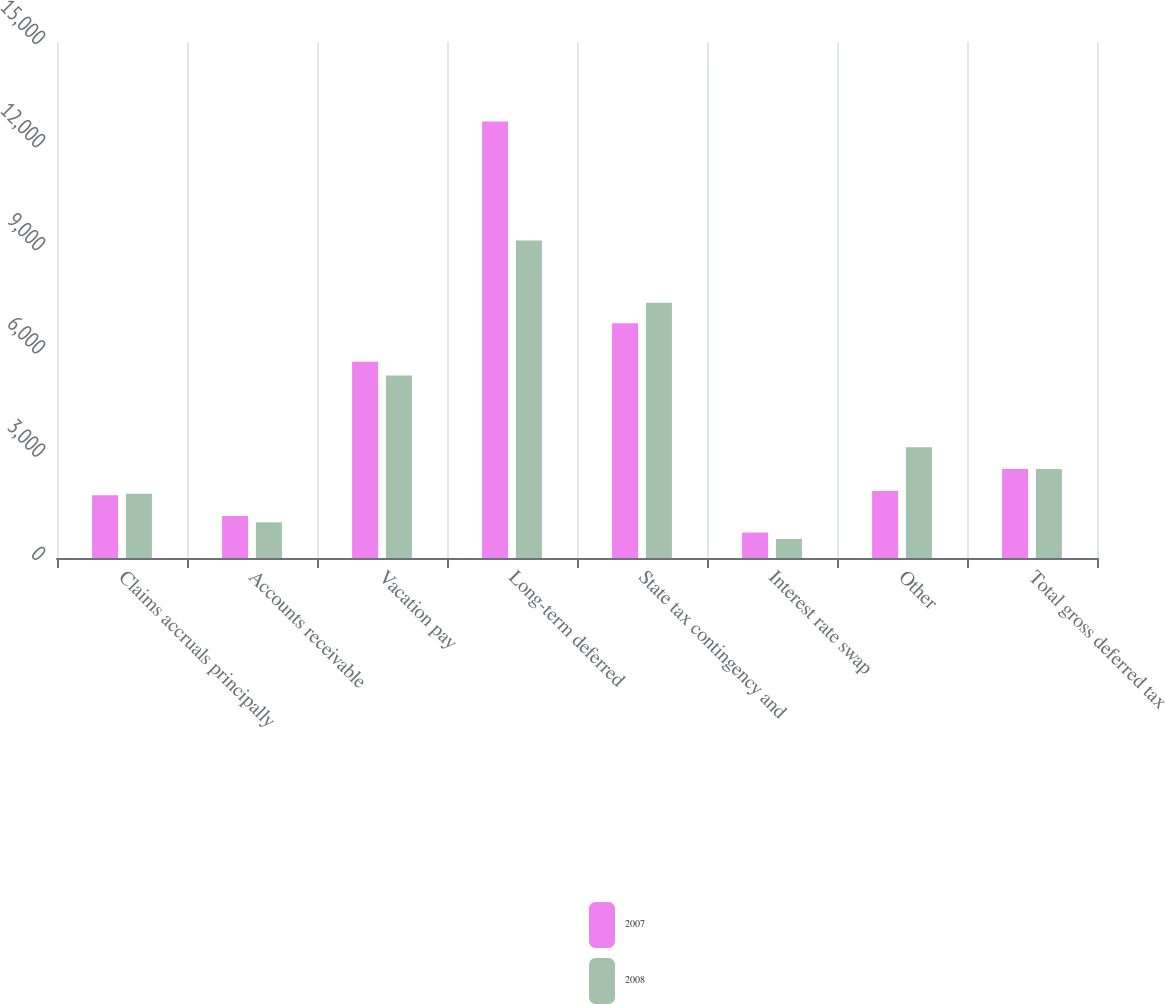Convert chart to OTSL. <chart><loc_0><loc_0><loc_500><loc_500><stacked_bar_chart><ecel><fcel>Claims accruals principally<fcel>Accounts receivable<fcel>Vacation pay<fcel>Long-term deferred<fcel>State tax contingency and<fcel>Interest rate swap<fcel>Other<fcel>Total gross deferred tax<nl><fcel>2007<fcel>1826<fcel>1223<fcel>5703<fcel>12686<fcel>6823<fcel>740<fcel>1947<fcel>2584.5<nl><fcel>2008<fcel>1865<fcel>1037<fcel>5308<fcel>9227<fcel>7422<fcel>554<fcel>3222<fcel>2584.5<nl></chart> 